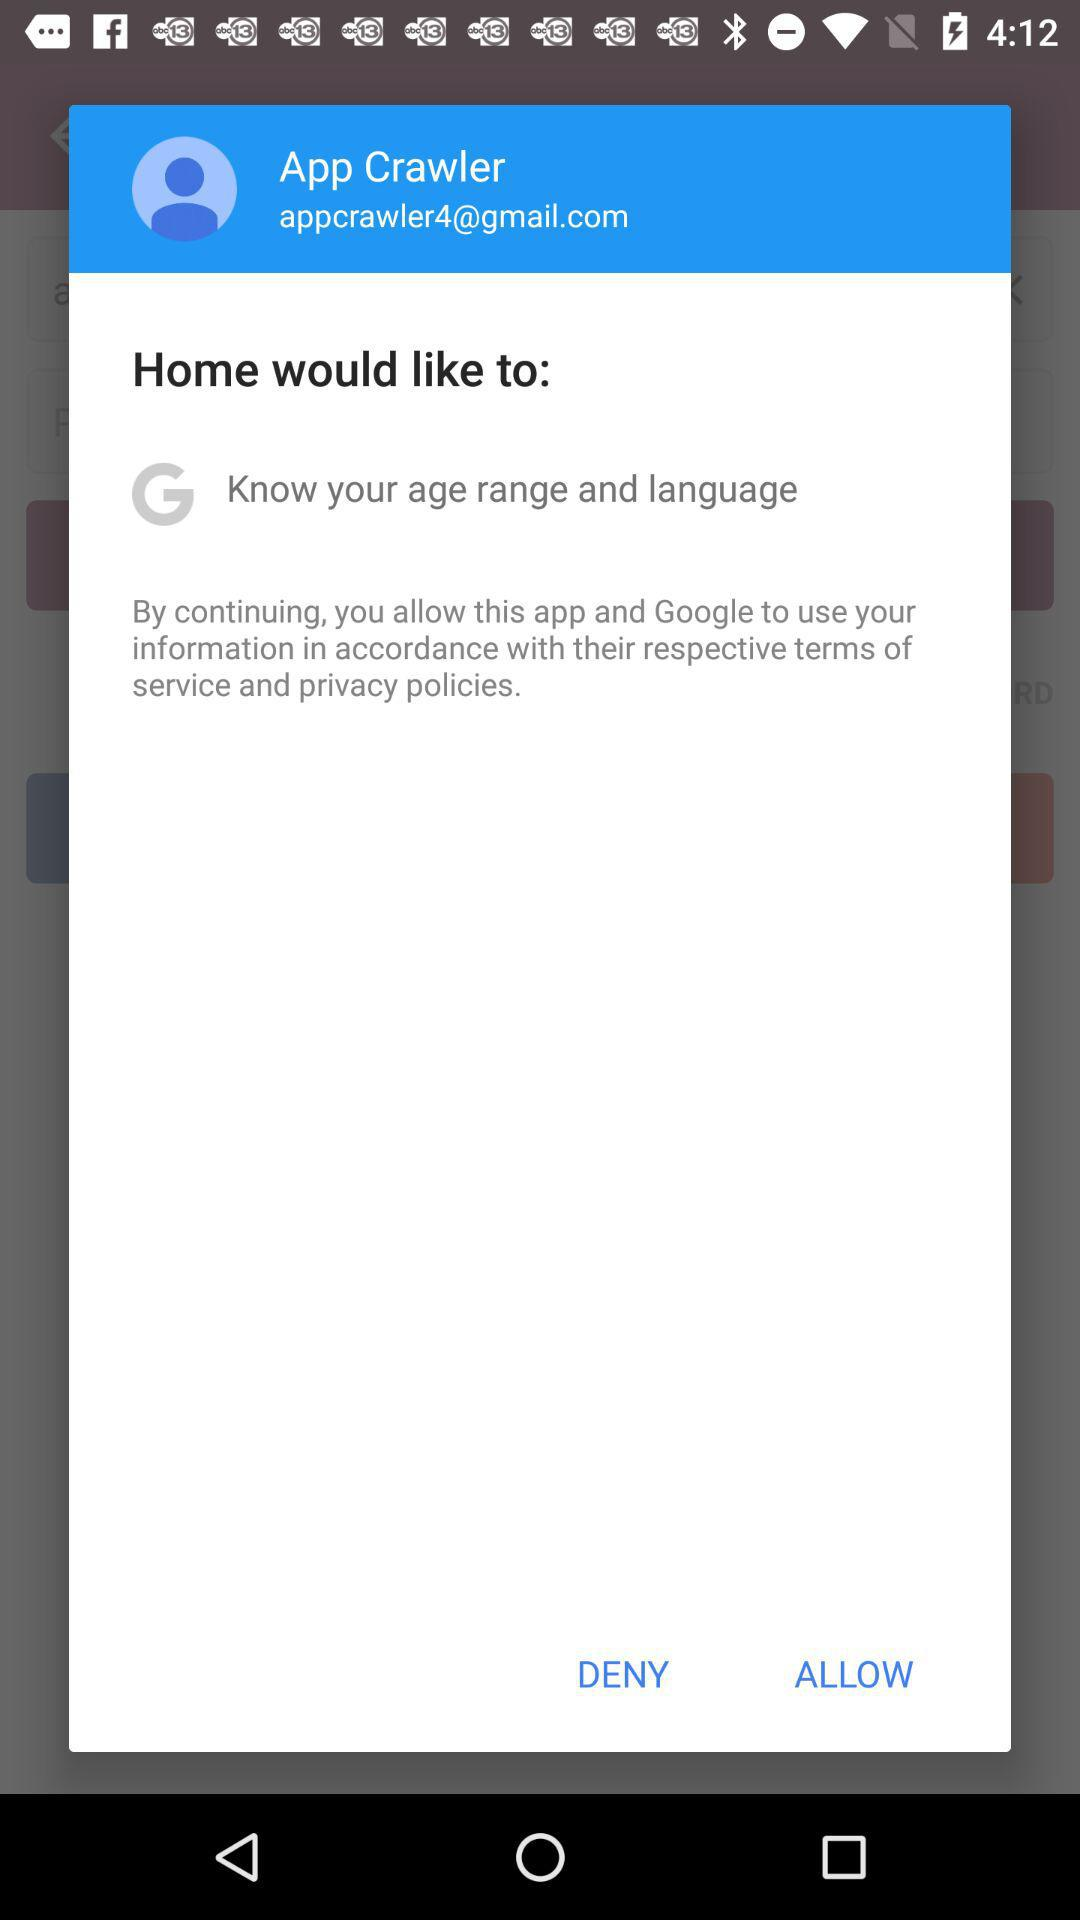Why might the app need to know my age range and language? Apps typically request to know your age range and language to provide a more personalized and age-appropriate experience. Language settings ensure that the app operates in a language you understand, enhancing usability. Is it safe to allow these permissions? Generally, allowing an app to know your age range and language is considered safe as these are not sensitive permissions. However, always ensure the app is trustworthy and check its reviews and privacy policy before granting permissions. 